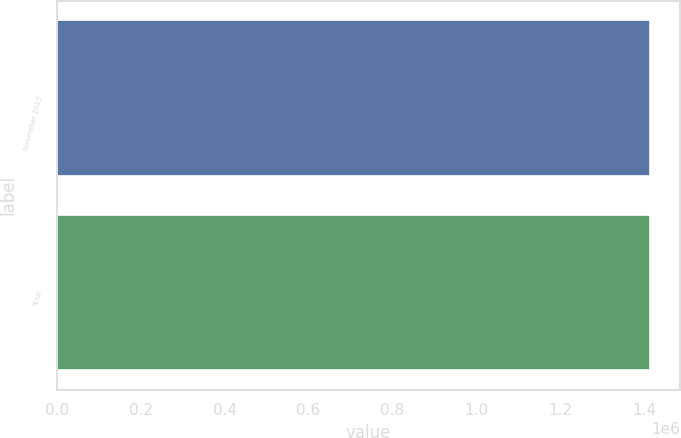Convert chart to OTSL. <chart><loc_0><loc_0><loc_500><loc_500><bar_chart><fcel>November 2015<fcel>Total<nl><fcel>1.41496e+06<fcel>1.41496e+06<nl></chart> 